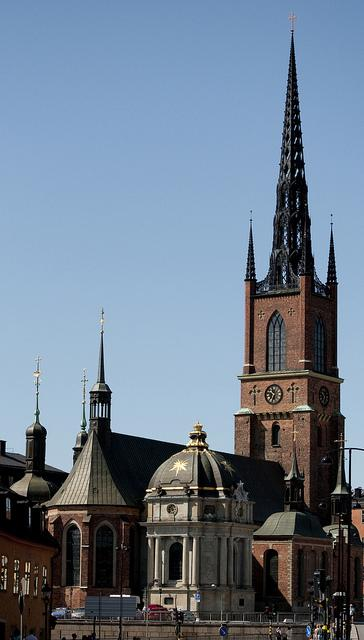What design is next to the clock on the largest building? Please explain your reasoning. cross. There are crosses beside the clock on the building tower. 